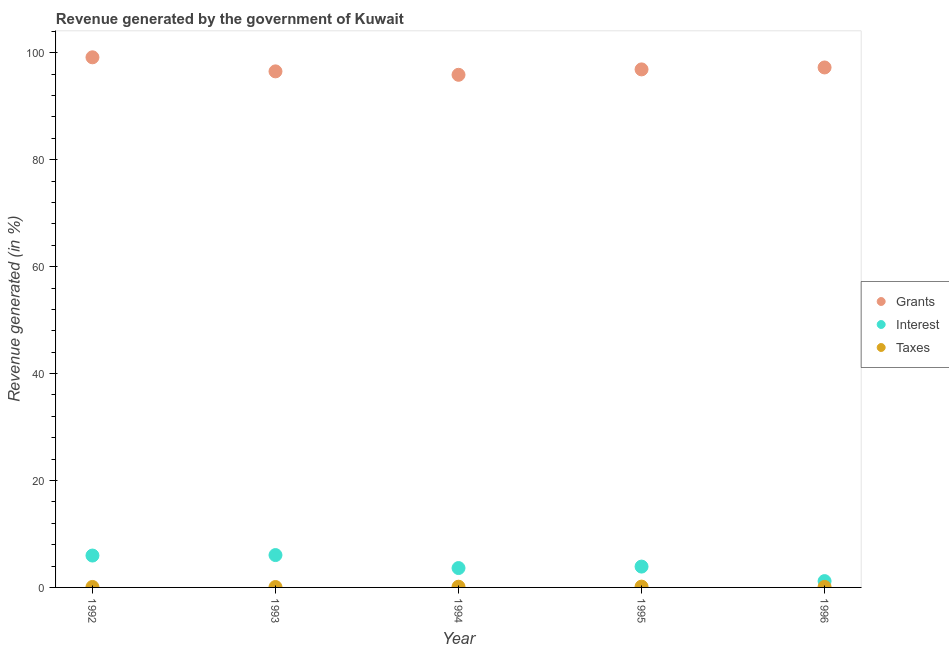Is the number of dotlines equal to the number of legend labels?
Your response must be concise. Yes. What is the percentage of revenue generated by grants in 1994?
Offer a very short reply. 95.87. Across all years, what is the maximum percentage of revenue generated by interest?
Keep it short and to the point. 6.05. Across all years, what is the minimum percentage of revenue generated by grants?
Offer a terse response. 95.87. In which year was the percentage of revenue generated by interest maximum?
Provide a short and direct response. 1993. In which year was the percentage of revenue generated by taxes minimum?
Provide a succinct answer. 1993. What is the total percentage of revenue generated by taxes in the graph?
Your answer should be compact. 0.55. What is the difference between the percentage of revenue generated by taxes in 1993 and that in 1995?
Ensure brevity in your answer.  -0.07. What is the difference between the percentage of revenue generated by taxes in 1993 and the percentage of revenue generated by grants in 1996?
Your answer should be very brief. -97.17. What is the average percentage of revenue generated by grants per year?
Ensure brevity in your answer.  97.13. In the year 1993, what is the difference between the percentage of revenue generated by interest and percentage of revenue generated by grants?
Your response must be concise. -90.46. In how many years, is the percentage of revenue generated by grants greater than 100 %?
Ensure brevity in your answer.  0. What is the ratio of the percentage of revenue generated by interest in 1994 to that in 1996?
Make the answer very short. 3.07. Is the percentage of revenue generated by interest in 1992 less than that in 1993?
Keep it short and to the point. Yes. Is the difference between the percentage of revenue generated by interest in 1992 and 1996 greater than the difference between the percentage of revenue generated by taxes in 1992 and 1996?
Keep it short and to the point. Yes. What is the difference between the highest and the second highest percentage of revenue generated by taxes?
Keep it short and to the point. 0.02. What is the difference between the highest and the lowest percentage of revenue generated by grants?
Make the answer very short. 3.27. In how many years, is the percentage of revenue generated by taxes greater than the average percentage of revenue generated by taxes taken over all years?
Your response must be concise. 2. Is it the case that in every year, the sum of the percentage of revenue generated by grants and percentage of revenue generated by interest is greater than the percentage of revenue generated by taxes?
Ensure brevity in your answer.  Yes. Does the percentage of revenue generated by taxes monotonically increase over the years?
Your answer should be compact. No. Is the percentage of revenue generated by interest strictly greater than the percentage of revenue generated by taxes over the years?
Your answer should be very brief. Yes. Is the percentage of revenue generated by interest strictly less than the percentage of revenue generated by taxes over the years?
Your answer should be compact. No. How many dotlines are there?
Give a very brief answer. 3. How many years are there in the graph?
Offer a terse response. 5. Does the graph contain grids?
Ensure brevity in your answer.  No. Where does the legend appear in the graph?
Make the answer very short. Center right. What is the title of the graph?
Give a very brief answer. Revenue generated by the government of Kuwait. Does "Male employers" appear as one of the legend labels in the graph?
Provide a short and direct response. No. What is the label or title of the Y-axis?
Offer a very short reply. Revenue generated (in %). What is the Revenue generated (in %) of Grants in 1992?
Make the answer very short. 99.15. What is the Revenue generated (in %) of Interest in 1992?
Give a very brief answer. 5.96. What is the Revenue generated (in %) of Taxes in 1992?
Offer a very short reply. 0.09. What is the Revenue generated (in %) of Grants in 1993?
Offer a terse response. 96.52. What is the Revenue generated (in %) in Interest in 1993?
Make the answer very short. 6.05. What is the Revenue generated (in %) of Taxes in 1993?
Make the answer very short. 0.08. What is the Revenue generated (in %) of Grants in 1994?
Provide a short and direct response. 95.87. What is the Revenue generated (in %) in Interest in 1994?
Your answer should be compact. 3.62. What is the Revenue generated (in %) of Taxes in 1994?
Your answer should be very brief. 0.13. What is the Revenue generated (in %) in Grants in 1995?
Make the answer very short. 96.89. What is the Revenue generated (in %) in Interest in 1995?
Offer a terse response. 3.9. What is the Revenue generated (in %) of Taxes in 1995?
Keep it short and to the point. 0.15. What is the Revenue generated (in %) in Grants in 1996?
Give a very brief answer. 97.25. What is the Revenue generated (in %) in Interest in 1996?
Your answer should be very brief. 1.18. What is the Revenue generated (in %) of Taxes in 1996?
Your answer should be compact. 0.1. Across all years, what is the maximum Revenue generated (in %) in Grants?
Give a very brief answer. 99.15. Across all years, what is the maximum Revenue generated (in %) of Interest?
Your answer should be very brief. 6.05. Across all years, what is the maximum Revenue generated (in %) of Taxes?
Make the answer very short. 0.15. Across all years, what is the minimum Revenue generated (in %) of Grants?
Offer a very short reply. 95.87. Across all years, what is the minimum Revenue generated (in %) in Interest?
Make the answer very short. 1.18. Across all years, what is the minimum Revenue generated (in %) in Taxes?
Provide a short and direct response. 0.08. What is the total Revenue generated (in %) in Grants in the graph?
Make the answer very short. 485.67. What is the total Revenue generated (in %) in Interest in the graph?
Offer a very short reply. 20.71. What is the total Revenue generated (in %) in Taxes in the graph?
Make the answer very short. 0.55. What is the difference between the Revenue generated (in %) in Grants in 1992 and that in 1993?
Offer a very short reply. 2.63. What is the difference between the Revenue generated (in %) in Interest in 1992 and that in 1993?
Provide a succinct answer. -0.09. What is the difference between the Revenue generated (in %) in Taxes in 1992 and that in 1993?
Keep it short and to the point. 0.01. What is the difference between the Revenue generated (in %) in Grants in 1992 and that in 1994?
Make the answer very short. 3.27. What is the difference between the Revenue generated (in %) in Interest in 1992 and that in 1994?
Offer a very short reply. 2.34. What is the difference between the Revenue generated (in %) in Taxes in 1992 and that in 1994?
Offer a terse response. -0.05. What is the difference between the Revenue generated (in %) of Grants in 1992 and that in 1995?
Keep it short and to the point. 2.26. What is the difference between the Revenue generated (in %) of Interest in 1992 and that in 1995?
Provide a short and direct response. 2.06. What is the difference between the Revenue generated (in %) of Taxes in 1992 and that in 1995?
Provide a succinct answer. -0.06. What is the difference between the Revenue generated (in %) in Grants in 1992 and that in 1996?
Give a very brief answer. 1.9. What is the difference between the Revenue generated (in %) of Interest in 1992 and that in 1996?
Give a very brief answer. 4.78. What is the difference between the Revenue generated (in %) of Taxes in 1992 and that in 1996?
Keep it short and to the point. -0.01. What is the difference between the Revenue generated (in %) of Grants in 1993 and that in 1994?
Give a very brief answer. 0.64. What is the difference between the Revenue generated (in %) in Interest in 1993 and that in 1994?
Offer a terse response. 2.43. What is the difference between the Revenue generated (in %) in Taxes in 1993 and that in 1994?
Offer a very short reply. -0.06. What is the difference between the Revenue generated (in %) in Grants in 1993 and that in 1995?
Offer a very short reply. -0.37. What is the difference between the Revenue generated (in %) in Interest in 1993 and that in 1995?
Provide a short and direct response. 2.15. What is the difference between the Revenue generated (in %) in Taxes in 1993 and that in 1995?
Keep it short and to the point. -0.07. What is the difference between the Revenue generated (in %) of Grants in 1993 and that in 1996?
Your answer should be very brief. -0.73. What is the difference between the Revenue generated (in %) of Interest in 1993 and that in 1996?
Keep it short and to the point. 4.87. What is the difference between the Revenue generated (in %) of Taxes in 1993 and that in 1996?
Offer a terse response. -0.02. What is the difference between the Revenue generated (in %) in Grants in 1994 and that in 1995?
Ensure brevity in your answer.  -1.01. What is the difference between the Revenue generated (in %) of Interest in 1994 and that in 1995?
Offer a very short reply. -0.27. What is the difference between the Revenue generated (in %) of Taxes in 1994 and that in 1995?
Make the answer very short. -0.02. What is the difference between the Revenue generated (in %) of Grants in 1994 and that in 1996?
Ensure brevity in your answer.  -1.37. What is the difference between the Revenue generated (in %) in Interest in 1994 and that in 1996?
Your answer should be compact. 2.44. What is the difference between the Revenue generated (in %) in Taxes in 1994 and that in 1996?
Offer a very short reply. 0.04. What is the difference between the Revenue generated (in %) in Grants in 1995 and that in 1996?
Your answer should be very brief. -0.36. What is the difference between the Revenue generated (in %) of Interest in 1995 and that in 1996?
Provide a succinct answer. 2.72. What is the difference between the Revenue generated (in %) of Taxes in 1995 and that in 1996?
Make the answer very short. 0.06. What is the difference between the Revenue generated (in %) in Grants in 1992 and the Revenue generated (in %) in Interest in 1993?
Give a very brief answer. 93.09. What is the difference between the Revenue generated (in %) in Grants in 1992 and the Revenue generated (in %) in Taxes in 1993?
Offer a terse response. 99.07. What is the difference between the Revenue generated (in %) in Interest in 1992 and the Revenue generated (in %) in Taxes in 1993?
Offer a very short reply. 5.88. What is the difference between the Revenue generated (in %) in Grants in 1992 and the Revenue generated (in %) in Interest in 1994?
Keep it short and to the point. 95.52. What is the difference between the Revenue generated (in %) of Grants in 1992 and the Revenue generated (in %) of Taxes in 1994?
Provide a short and direct response. 99.01. What is the difference between the Revenue generated (in %) in Interest in 1992 and the Revenue generated (in %) in Taxes in 1994?
Offer a terse response. 5.83. What is the difference between the Revenue generated (in %) of Grants in 1992 and the Revenue generated (in %) of Interest in 1995?
Give a very brief answer. 95.25. What is the difference between the Revenue generated (in %) of Grants in 1992 and the Revenue generated (in %) of Taxes in 1995?
Keep it short and to the point. 98.99. What is the difference between the Revenue generated (in %) of Interest in 1992 and the Revenue generated (in %) of Taxes in 1995?
Provide a short and direct response. 5.81. What is the difference between the Revenue generated (in %) of Grants in 1992 and the Revenue generated (in %) of Interest in 1996?
Keep it short and to the point. 97.96. What is the difference between the Revenue generated (in %) of Grants in 1992 and the Revenue generated (in %) of Taxes in 1996?
Offer a very short reply. 99.05. What is the difference between the Revenue generated (in %) of Interest in 1992 and the Revenue generated (in %) of Taxes in 1996?
Make the answer very short. 5.87. What is the difference between the Revenue generated (in %) in Grants in 1993 and the Revenue generated (in %) in Interest in 1994?
Provide a short and direct response. 92.89. What is the difference between the Revenue generated (in %) of Grants in 1993 and the Revenue generated (in %) of Taxes in 1994?
Offer a very short reply. 96.38. What is the difference between the Revenue generated (in %) in Interest in 1993 and the Revenue generated (in %) in Taxes in 1994?
Your response must be concise. 5.92. What is the difference between the Revenue generated (in %) in Grants in 1993 and the Revenue generated (in %) in Interest in 1995?
Ensure brevity in your answer.  92.62. What is the difference between the Revenue generated (in %) in Grants in 1993 and the Revenue generated (in %) in Taxes in 1995?
Your response must be concise. 96.36. What is the difference between the Revenue generated (in %) in Interest in 1993 and the Revenue generated (in %) in Taxes in 1995?
Keep it short and to the point. 5.9. What is the difference between the Revenue generated (in %) of Grants in 1993 and the Revenue generated (in %) of Interest in 1996?
Provide a short and direct response. 95.33. What is the difference between the Revenue generated (in %) in Grants in 1993 and the Revenue generated (in %) in Taxes in 1996?
Give a very brief answer. 96.42. What is the difference between the Revenue generated (in %) of Interest in 1993 and the Revenue generated (in %) of Taxes in 1996?
Make the answer very short. 5.96. What is the difference between the Revenue generated (in %) of Grants in 1994 and the Revenue generated (in %) of Interest in 1995?
Offer a very short reply. 91.98. What is the difference between the Revenue generated (in %) of Grants in 1994 and the Revenue generated (in %) of Taxes in 1995?
Ensure brevity in your answer.  95.72. What is the difference between the Revenue generated (in %) in Interest in 1994 and the Revenue generated (in %) in Taxes in 1995?
Offer a terse response. 3.47. What is the difference between the Revenue generated (in %) in Grants in 1994 and the Revenue generated (in %) in Interest in 1996?
Provide a short and direct response. 94.69. What is the difference between the Revenue generated (in %) in Grants in 1994 and the Revenue generated (in %) in Taxes in 1996?
Offer a terse response. 95.78. What is the difference between the Revenue generated (in %) of Interest in 1994 and the Revenue generated (in %) of Taxes in 1996?
Give a very brief answer. 3.53. What is the difference between the Revenue generated (in %) of Grants in 1995 and the Revenue generated (in %) of Interest in 1996?
Offer a very short reply. 95.7. What is the difference between the Revenue generated (in %) of Grants in 1995 and the Revenue generated (in %) of Taxes in 1996?
Make the answer very short. 96.79. What is the difference between the Revenue generated (in %) in Interest in 1995 and the Revenue generated (in %) in Taxes in 1996?
Your answer should be very brief. 3.8. What is the average Revenue generated (in %) of Grants per year?
Your answer should be very brief. 97.13. What is the average Revenue generated (in %) in Interest per year?
Offer a terse response. 4.14. What is the average Revenue generated (in %) of Taxes per year?
Provide a short and direct response. 0.11. In the year 1992, what is the difference between the Revenue generated (in %) of Grants and Revenue generated (in %) of Interest?
Ensure brevity in your answer.  93.18. In the year 1992, what is the difference between the Revenue generated (in %) in Grants and Revenue generated (in %) in Taxes?
Keep it short and to the point. 99.06. In the year 1992, what is the difference between the Revenue generated (in %) of Interest and Revenue generated (in %) of Taxes?
Make the answer very short. 5.87. In the year 1993, what is the difference between the Revenue generated (in %) of Grants and Revenue generated (in %) of Interest?
Give a very brief answer. 90.46. In the year 1993, what is the difference between the Revenue generated (in %) of Grants and Revenue generated (in %) of Taxes?
Provide a short and direct response. 96.44. In the year 1993, what is the difference between the Revenue generated (in %) of Interest and Revenue generated (in %) of Taxes?
Provide a succinct answer. 5.97. In the year 1994, what is the difference between the Revenue generated (in %) in Grants and Revenue generated (in %) in Interest?
Make the answer very short. 92.25. In the year 1994, what is the difference between the Revenue generated (in %) of Grants and Revenue generated (in %) of Taxes?
Make the answer very short. 95.74. In the year 1994, what is the difference between the Revenue generated (in %) of Interest and Revenue generated (in %) of Taxes?
Give a very brief answer. 3.49. In the year 1995, what is the difference between the Revenue generated (in %) in Grants and Revenue generated (in %) in Interest?
Provide a succinct answer. 92.99. In the year 1995, what is the difference between the Revenue generated (in %) in Grants and Revenue generated (in %) in Taxes?
Make the answer very short. 96.73. In the year 1995, what is the difference between the Revenue generated (in %) in Interest and Revenue generated (in %) in Taxes?
Make the answer very short. 3.75. In the year 1996, what is the difference between the Revenue generated (in %) of Grants and Revenue generated (in %) of Interest?
Keep it short and to the point. 96.07. In the year 1996, what is the difference between the Revenue generated (in %) of Grants and Revenue generated (in %) of Taxes?
Your answer should be very brief. 97.15. In the year 1996, what is the difference between the Revenue generated (in %) of Interest and Revenue generated (in %) of Taxes?
Keep it short and to the point. 1.09. What is the ratio of the Revenue generated (in %) of Grants in 1992 to that in 1993?
Your answer should be very brief. 1.03. What is the ratio of the Revenue generated (in %) in Interest in 1992 to that in 1993?
Your answer should be compact. 0.99. What is the ratio of the Revenue generated (in %) in Taxes in 1992 to that in 1993?
Keep it short and to the point. 1.12. What is the ratio of the Revenue generated (in %) of Grants in 1992 to that in 1994?
Offer a very short reply. 1.03. What is the ratio of the Revenue generated (in %) of Interest in 1992 to that in 1994?
Offer a very short reply. 1.65. What is the ratio of the Revenue generated (in %) in Taxes in 1992 to that in 1994?
Keep it short and to the point. 0.66. What is the ratio of the Revenue generated (in %) in Grants in 1992 to that in 1995?
Keep it short and to the point. 1.02. What is the ratio of the Revenue generated (in %) of Interest in 1992 to that in 1995?
Ensure brevity in your answer.  1.53. What is the ratio of the Revenue generated (in %) of Taxes in 1992 to that in 1995?
Offer a terse response. 0.58. What is the ratio of the Revenue generated (in %) in Grants in 1992 to that in 1996?
Keep it short and to the point. 1.02. What is the ratio of the Revenue generated (in %) of Interest in 1992 to that in 1996?
Offer a very short reply. 5.05. What is the ratio of the Revenue generated (in %) of Taxes in 1992 to that in 1996?
Your response must be concise. 0.92. What is the ratio of the Revenue generated (in %) in Grants in 1993 to that in 1994?
Keep it short and to the point. 1.01. What is the ratio of the Revenue generated (in %) in Interest in 1993 to that in 1994?
Provide a succinct answer. 1.67. What is the ratio of the Revenue generated (in %) of Taxes in 1993 to that in 1994?
Provide a succinct answer. 0.59. What is the ratio of the Revenue generated (in %) in Grants in 1993 to that in 1995?
Provide a short and direct response. 1. What is the ratio of the Revenue generated (in %) in Interest in 1993 to that in 1995?
Offer a very short reply. 1.55. What is the ratio of the Revenue generated (in %) in Taxes in 1993 to that in 1995?
Make the answer very short. 0.52. What is the ratio of the Revenue generated (in %) in Interest in 1993 to that in 1996?
Make the answer very short. 5.12. What is the ratio of the Revenue generated (in %) in Taxes in 1993 to that in 1996?
Offer a very short reply. 0.82. What is the ratio of the Revenue generated (in %) in Grants in 1994 to that in 1995?
Make the answer very short. 0.99. What is the ratio of the Revenue generated (in %) of Interest in 1994 to that in 1995?
Offer a very short reply. 0.93. What is the ratio of the Revenue generated (in %) in Taxes in 1994 to that in 1995?
Offer a very short reply. 0.89. What is the ratio of the Revenue generated (in %) in Grants in 1994 to that in 1996?
Ensure brevity in your answer.  0.99. What is the ratio of the Revenue generated (in %) in Interest in 1994 to that in 1996?
Give a very brief answer. 3.07. What is the ratio of the Revenue generated (in %) of Taxes in 1994 to that in 1996?
Provide a short and direct response. 1.4. What is the ratio of the Revenue generated (in %) of Grants in 1995 to that in 1996?
Provide a short and direct response. 1. What is the ratio of the Revenue generated (in %) of Interest in 1995 to that in 1996?
Your response must be concise. 3.3. What is the ratio of the Revenue generated (in %) in Taxes in 1995 to that in 1996?
Offer a terse response. 1.58. What is the difference between the highest and the second highest Revenue generated (in %) of Grants?
Make the answer very short. 1.9. What is the difference between the highest and the second highest Revenue generated (in %) in Interest?
Make the answer very short. 0.09. What is the difference between the highest and the second highest Revenue generated (in %) of Taxes?
Make the answer very short. 0.02. What is the difference between the highest and the lowest Revenue generated (in %) in Grants?
Keep it short and to the point. 3.27. What is the difference between the highest and the lowest Revenue generated (in %) of Interest?
Your response must be concise. 4.87. What is the difference between the highest and the lowest Revenue generated (in %) in Taxes?
Make the answer very short. 0.07. 